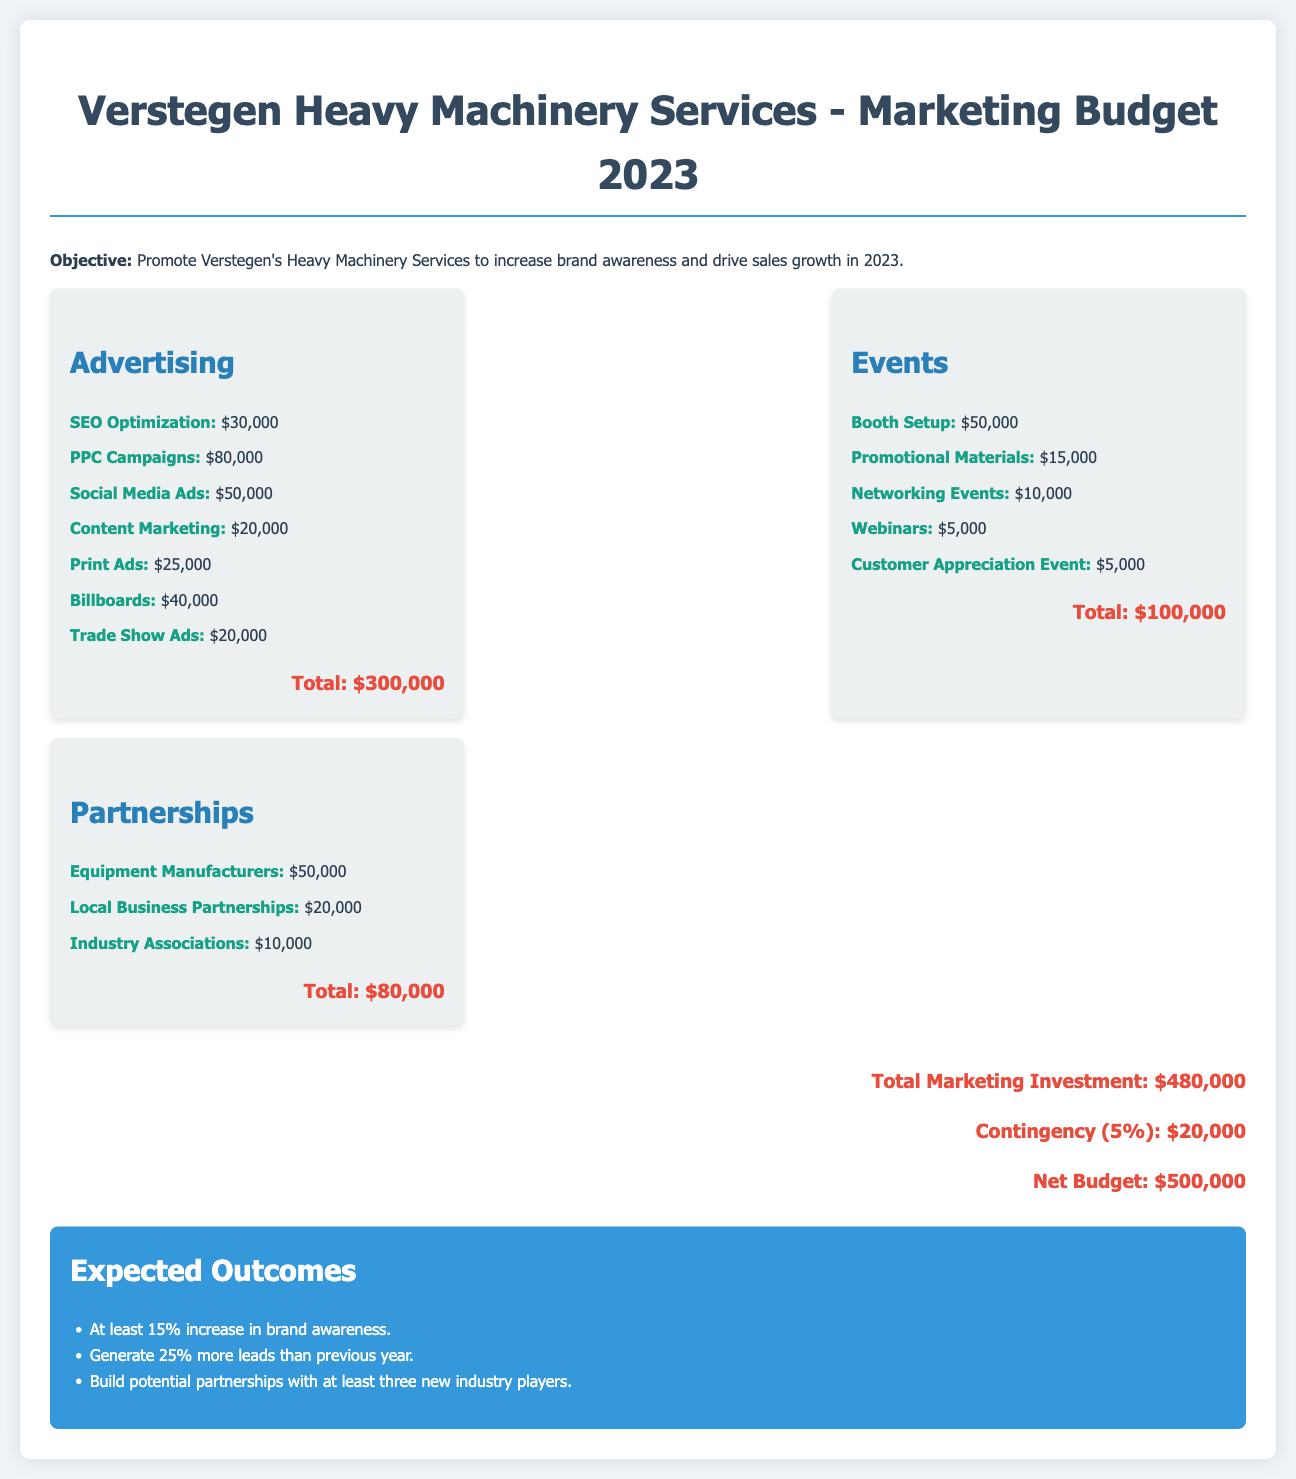What is the total budget for advertising? The total budget for advertising is calculated by adding up all individual advertising expenses, which amounts to $300,000.
Answer: $300,000 What is allocated for social media ads? The document lists the budget for social media ads specifically, which is $50,000.
Answer: $50,000 How much is budgeted for events in total? The total budget for events is found by summing all event-related costs, totaling $100,000.
Answer: $100,000 What is the budget for partnerships with equipment manufacturers? The budget specifically designated for partnerships with equipment manufacturers is detailed as $50,000.
Answer: $50,000 What is the total marketing investment including the contingency? The total marketing investment reflects all marketing-related expenditures including the contingency, which is $500,000.
Answer: $500,000 What is the expected increase in brand awareness? The document outlines that the expected increase in brand awareness is at least 15%.
Answer: 15% How much is budgeted for webinars under events? The budget allocated for webinars is specifically mentioned as $5,000.
Answer: $5,000 What percentage of the total budget is contingency? The contingency is calculated as 5% of the total marketing budget, amounting to $20,000.
Answer: 5% What is the total budget for promotional materials? The document specifically states that $15,000 is allocated for promotional materials under events.
Answer: $15,000 